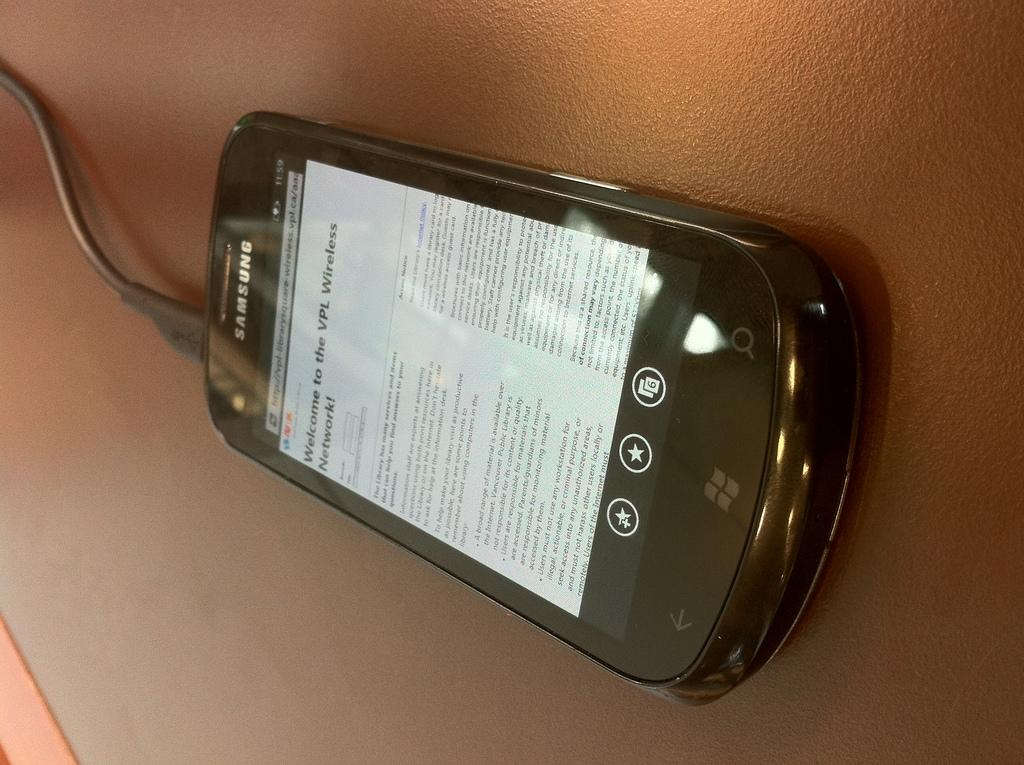<image>
Relay a brief, clear account of the picture shown. A black Samsung phone displays a website that welcomes the user to the VPL Wireless Network. 